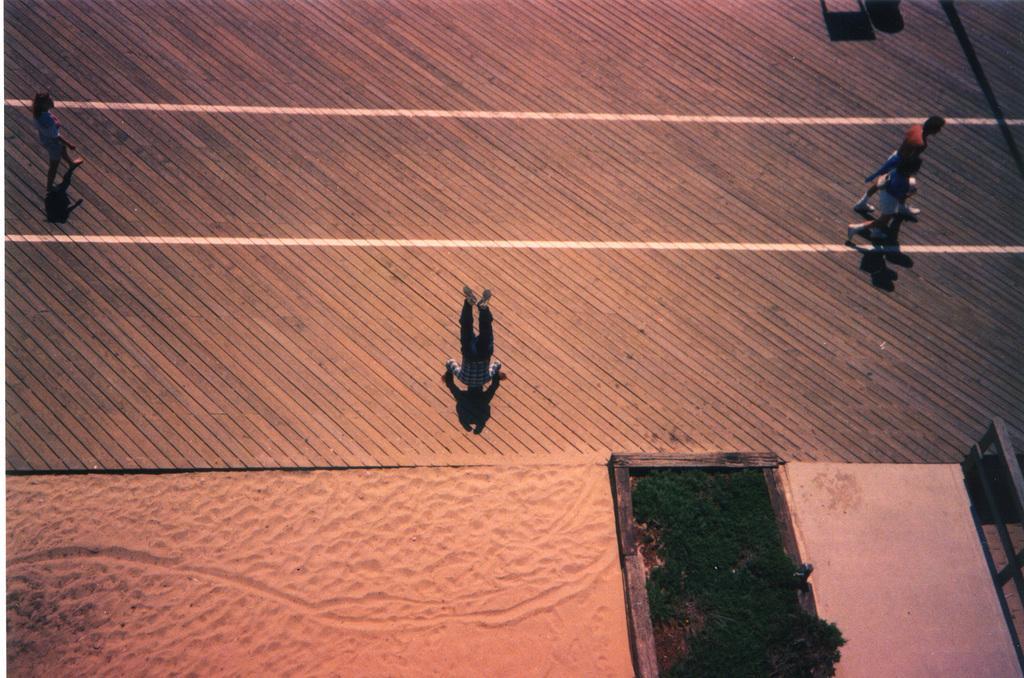Can you describe this image briefly? This picture is clicked outside. In the center we can see the group of persons. In the foreground we can see the mud and some portion of green grass. On the right we can see some objects. 